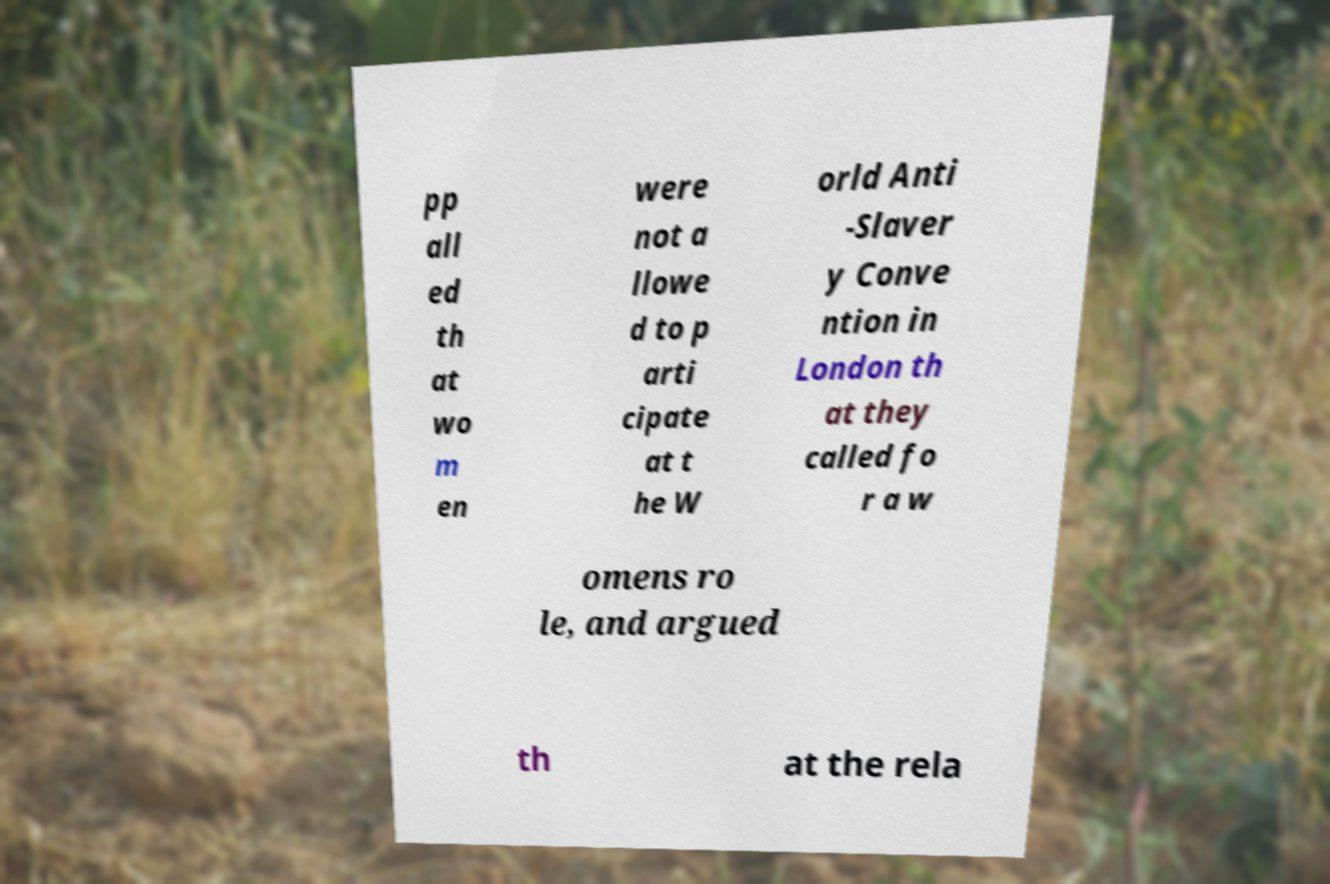I need the written content from this picture converted into text. Can you do that? pp all ed th at wo m en were not a llowe d to p arti cipate at t he W orld Anti -Slaver y Conve ntion in London th at they called fo r a w omens ro le, and argued th at the rela 